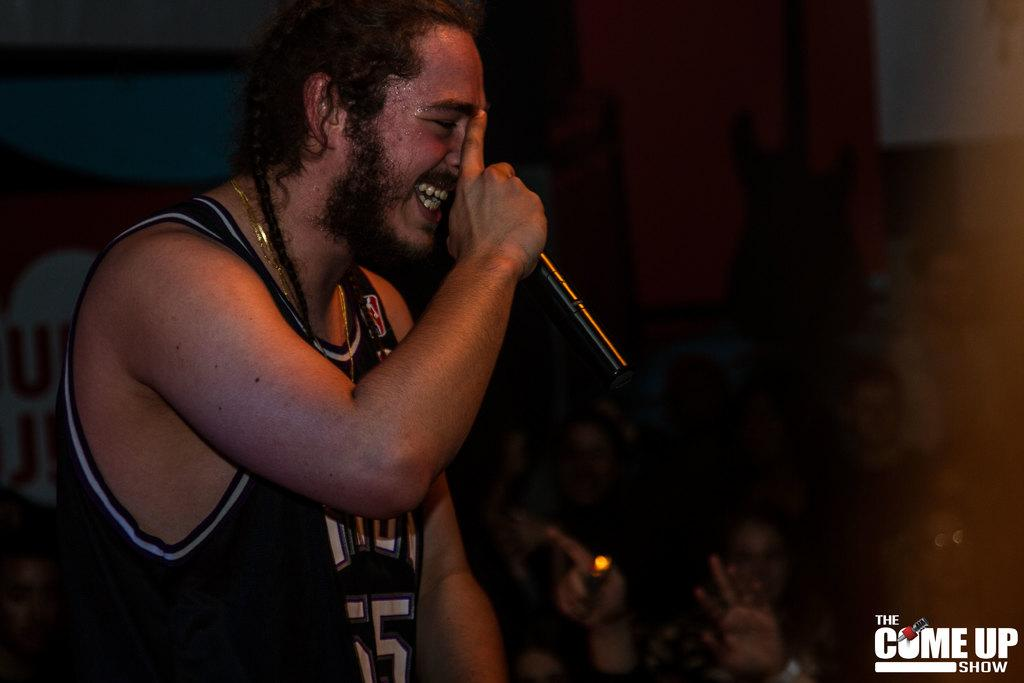What is the person in the image holding? The person in the image is holding a microphone. Who is present in the image besides the person holding the microphone? There is an audience in the image. How is the audience positioned in the image? The audience is sitting. What can be found in the right bottom corner of the image? There is text written in the right bottom corner of the image. Is there a body of water visible in the image? No, there is no body of water visible in the image. How does the rail system function in the image? There is no rail system present in the image. 